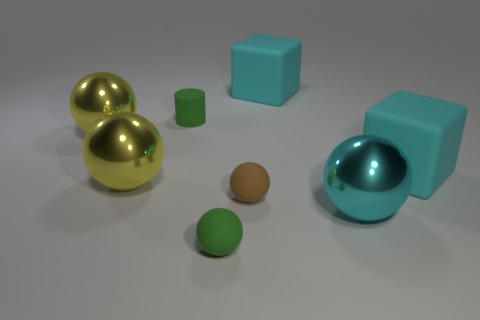There is a sphere that is to the left of the brown ball and in front of the brown matte object; what is its material?
Provide a short and direct response. Rubber. Are there fewer big cyan things to the right of the small brown object than green things?
Ensure brevity in your answer.  No. Do the small rubber object to the right of the small green sphere and the tiny matte cylinder have the same color?
Offer a very short reply. No. How many rubber objects are either green cylinders or large red cylinders?
Your answer should be compact. 1. Is there anything else that has the same size as the brown rubber thing?
Provide a succinct answer. Yes. What color is the tiny cylinder that is the same material as the brown ball?
Give a very brief answer. Green. What number of blocks are tiny green things or tiny matte objects?
Your answer should be very brief. 0. What number of things are either brown things or big matte things behind the green matte cylinder?
Ensure brevity in your answer.  2. Are there any large metal balls?
Make the answer very short. Yes. What number of small matte balls are the same color as the small cylinder?
Offer a terse response. 1. 